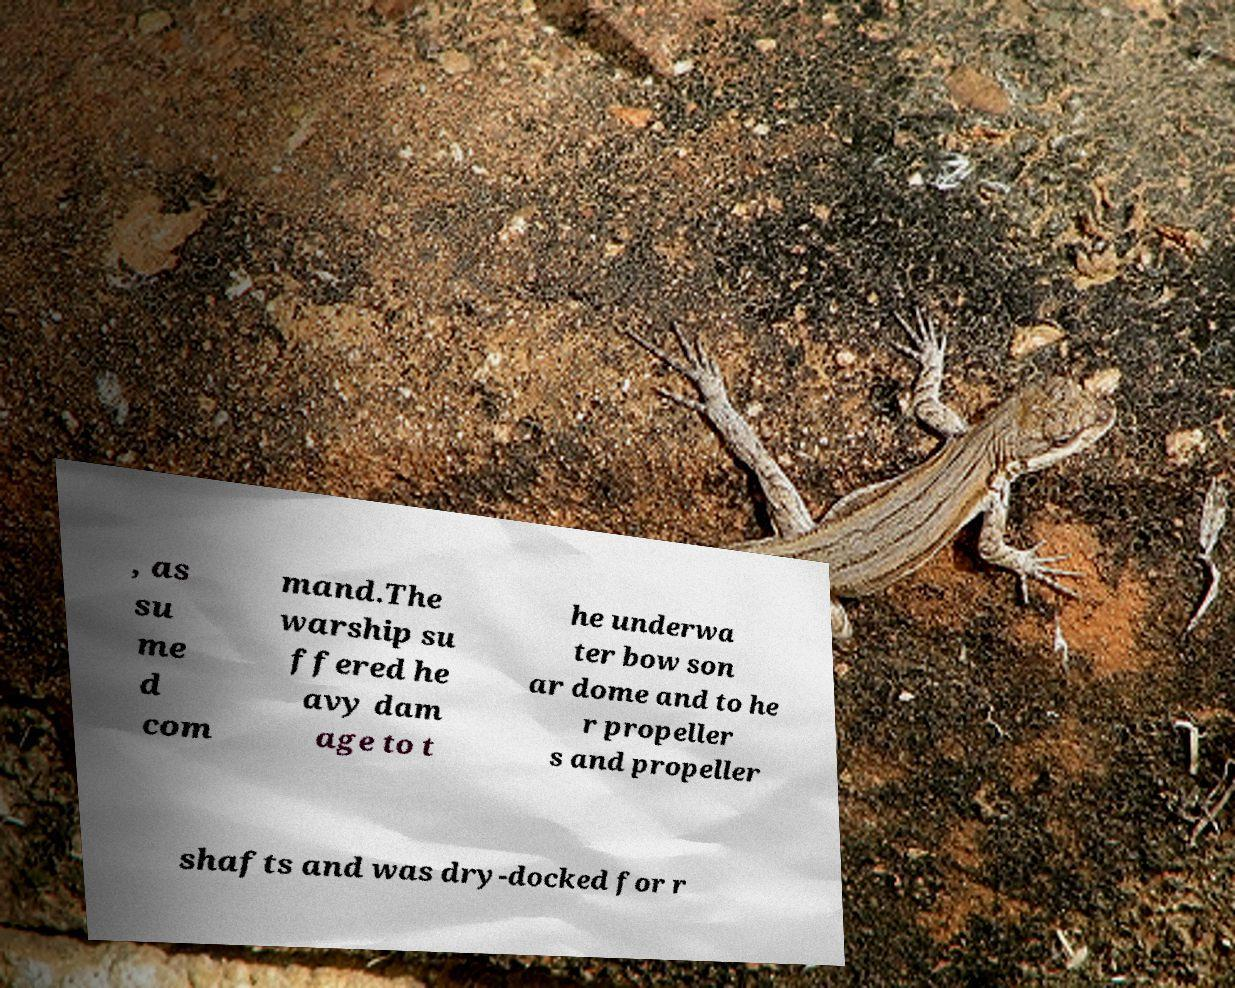Please identify and transcribe the text found in this image. , as su me d com mand.The warship su ffered he avy dam age to t he underwa ter bow son ar dome and to he r propeller s and propeller shafts and was dry-docked for r 